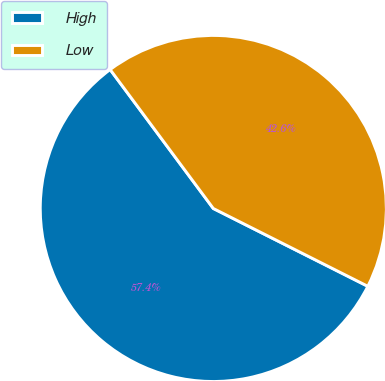<chart> <loc_0><loc_0><loc_500><loc_500><pie_chart><fcel>High<fcel>Low<nl><fcel>57.41%<fcel>42.59%<nl></chart> 